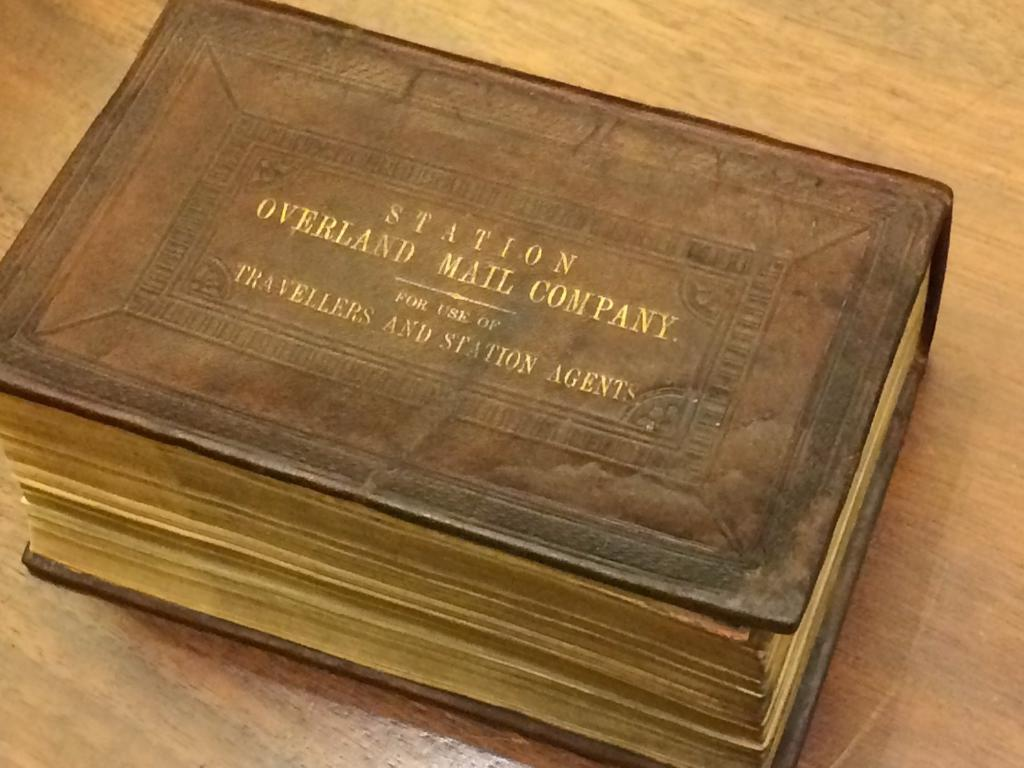<image>
Render a clear and concise summary of the photo. an old thick book titled Station Overland mail company sits on a wooden surface 